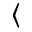Convert formula to latex. <formula><loc_0><loc_0><loc_500><loc_500>\langle</formula> 